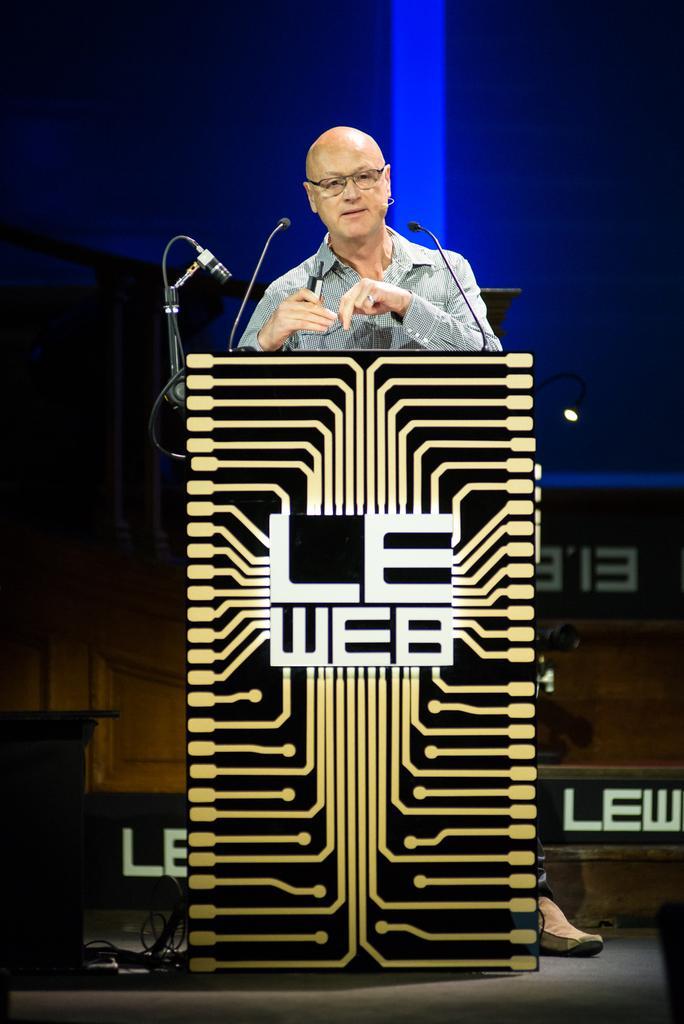Could you give a brief overview of what you see in this image? In this image I can see the person standing in front of the podium and I can also see few microphones and I can see the blue color background. 